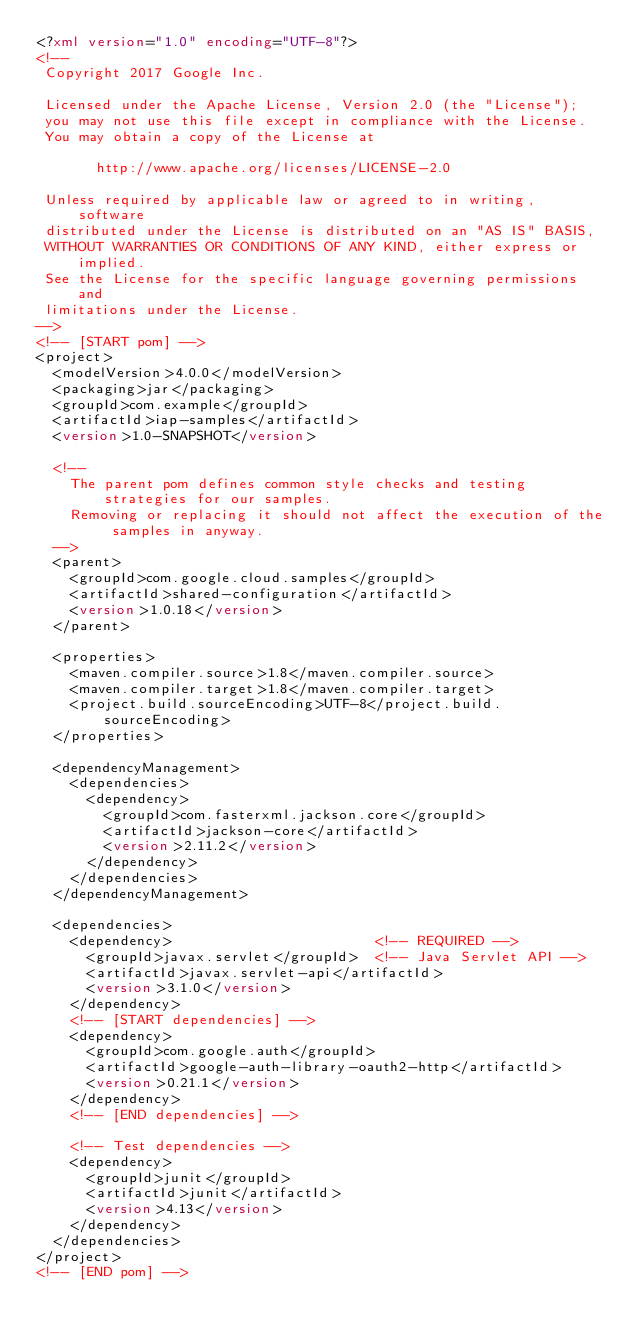<code> <loc_0><loc_0><loc_500><loc_500><_XML_><?xml version="1.0" encoding="UTF-8"?>
<!--
 Copyright 2017 Google Inc.

 Licensed under the Apache License, Version 2.0 (the "License");
 you may not use this file except in compliance with the License.
 You may obtain a copy of the License at

       http://www.apache.org/licenses/LICENSE-2.0

 Unless required by applicable law or agreed to in writing, software
 distributed under the License is distributed on an "AS IS" BASIS,
 WITHOUT WARRANTIES OR CONDITIONS OF ANY KIND, either express or implied.
 See the License for the specific language governing permissions and
 limitations under the License.
-->
<!-- [START pom] -->
<project>
  <modelVersion>4.0.0</modelVersion>
  <packaging>jar</packaging>
  <groupId>com.example</groupId>
  <artifactId>iap-samples</artifactId>
  <version>1.0-SNAPSHOT</version>

  <!--
    The parent pom defines common style checks and testing strategies for our samples.
    Removing or replacing it should not affect the execution of the samples in anyway.
  -->
  <parent>
    <groupId>com.google.cloud.samples</groupId>
    <artifactId>shared-configuration</artifactId>
    <version>1.0.18</version>
  </parent>

  <properties>
    <maven.compiler.source>1.8</maven.compiler.source>
    <maven.compiler.target>1.8</maven.compiler.target>
    <project.build.sourceEncoding>UTF-8</project.build.sourceEncoding>
  </properties>

  <dependencyManagement>
    <dependencies>
      <dependency>
        <groupId>com.fasterxml.jackson.core</groupId>
        <artifactId>jackson-core</artifactId>
        <version>2.11.2</version>
      </dependency>
    </dependencies>
  </dependencyManagement>

  <dependencies>
    <dependency>                        <!-- REQUIRED -->
      <groupId>javax.servlet</groupId>  <!-- Java Servlet API -->
      <artifactId>javax.servlet-api</artifactId>
      <version>3.1.0</version>
    </dependency>
    <!-- [START dependencies] -->
    <dependency>
      <groupId>com.google.auth</groupId>
      <artifactId>google-auth-library-oauth2-http</artifactId>
      <version>0.21.1</version>
    </dependency>
    <!-- [END dependencies] -->

    <!-- Test dependencies -->
    <dependency>
      <groupId>junit</groupId>
      <artifactId>junit</artifactId>
      <version>4.13</version>
    </dependency>
  </dependencies>
</project>
<!-- [END pom] -->
</code> 